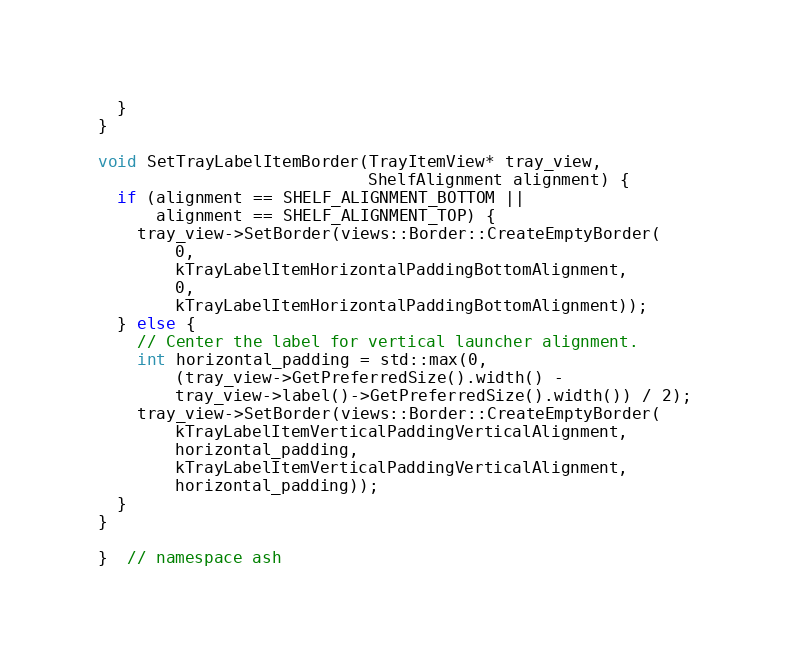<code> <loc_0><loc_0><loc_500><loc_500><_C++_>  }
}

void SetTrayLabelItemBorder(TrayItemView* tray_view,
                            ShelfAlignment alignment) {
  if (alignment == SHELF_ALIGNMENT_BOTTOM ||
      alignment == SHELF_ALIGNMENT_TOP) {
    tray_view->SetBorder(views::Border::CreateEmptyBorder(
        0,
        kTrayLabelItemHorizontalPaddingBottomAlignment,
        0,
        kTrayLabelItemHorizontalPaddingBottomAlignment));
  } else {
    // Center the label for vertical launcher alignment.
    int horizontal_padding = std::max(0,
        (tray_view->GetPreferredSize().width() -
        tray_view->label()->GetPreferredSize().width()) / 2);
    tray_view->SetBorder(views::Border::CreateEmptyBorder(
        kTrayLabelItemVerticalPaddingVerticalAlignment,
        horizontal_padding,
        kTrayLabelItemVerticalPaddingVerticalAlignment,
        horizontal_padding));
  }
}

}  // namespace ash
</code> 